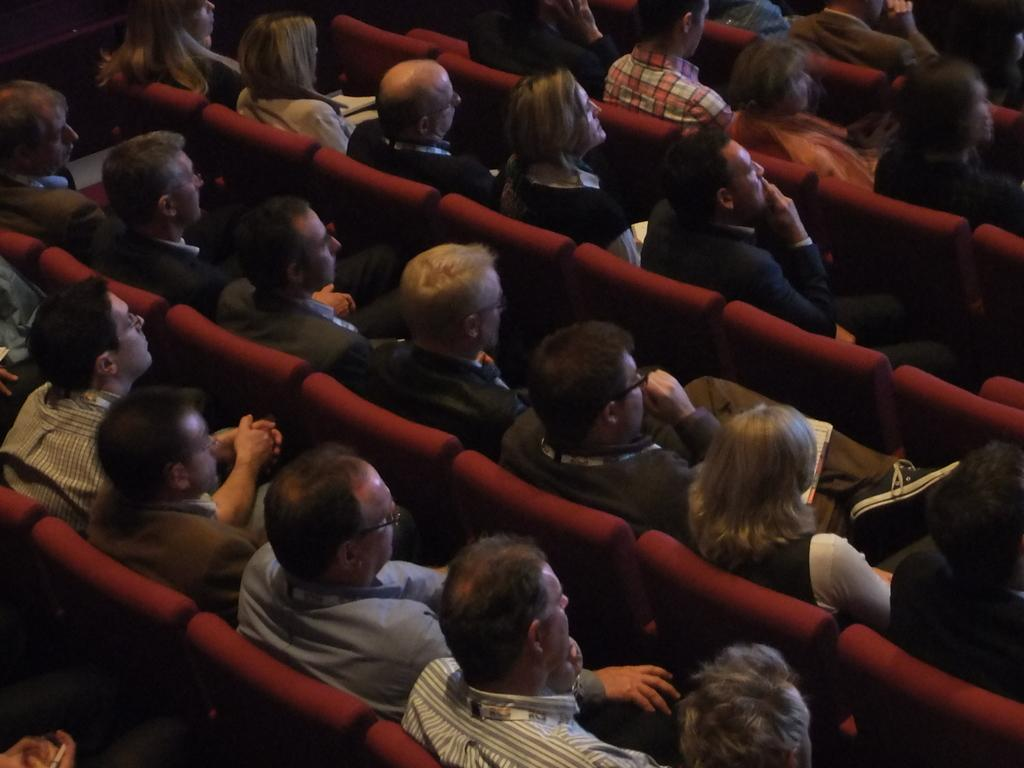How many people are in the image? There are people in the image, but the exact number is not specified. What are the people doing in the image? The people are sitting on chairs in the image. What might the people be looking at? The people are looking at something, but the specific object or scene is not mentioned in the facts. Where is the lunchroom located in the image? There is no mention of a lunchroom in the image or the facts provided. What type of vase can be seen on the table in the image? There is no vase present in the image. What baseball team are the people in the image supporting? There is no reference to baseball or any sports teams in the image or the facts provided. 